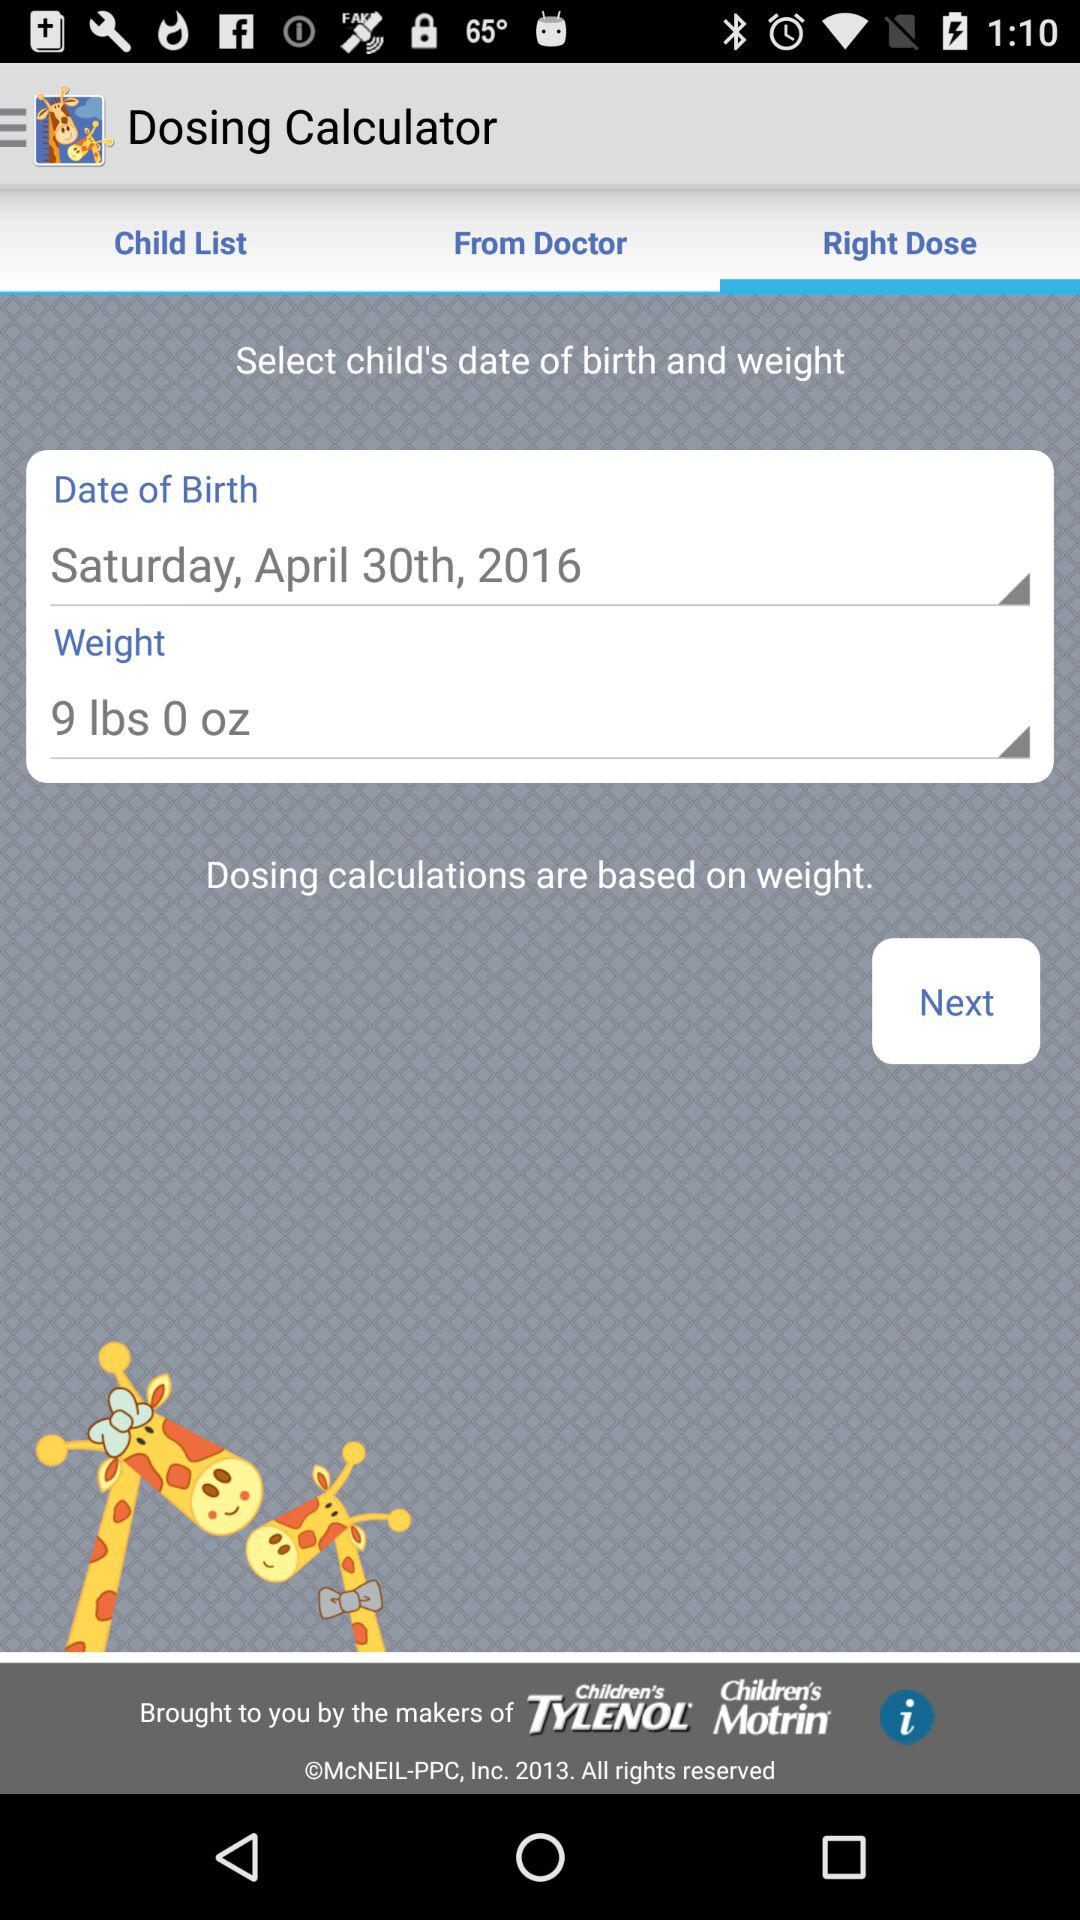How many lbs does the child weigh?
Answer the question using a single word or phrase. 9 